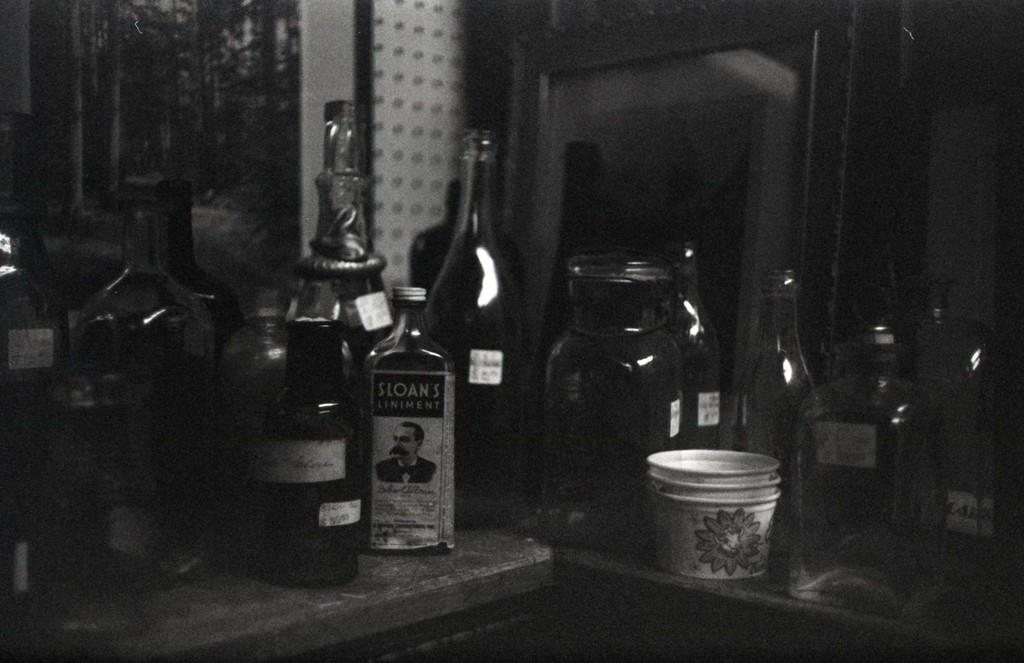What objects are on the table in the image? There are bottles and a cup on the table in the image. Can you describe the wall visible in the image? Unfortunately, the provided facts do not give any details about the wall, so we cannot describe it. How many objects are on the table in the image? There are three objects on the table: two bottles and a cup. What type of quartz can be seen in the stream near the table in the image? There is no quartz or stream present in the image; it only shows bottles, a cup, and a wall. How is the connection between the objects on the table established in the image? The provided facts do not mention any connections between the objects on the table, so we cannot determine how they are connected. 